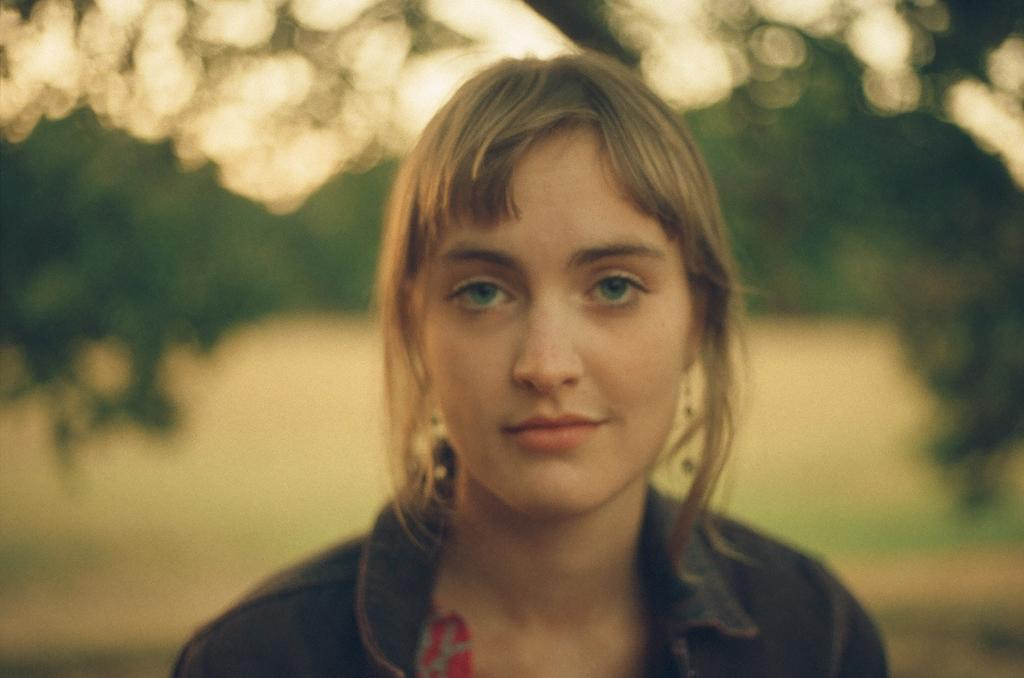Who is the main subject in the image? There is a woman in the image. Can you describe the background of the image? The background of the image is blurry. How many times does the woman's chin move in the image? There is no indication of the woman's chin moving in the image, as it is a still photograph. 